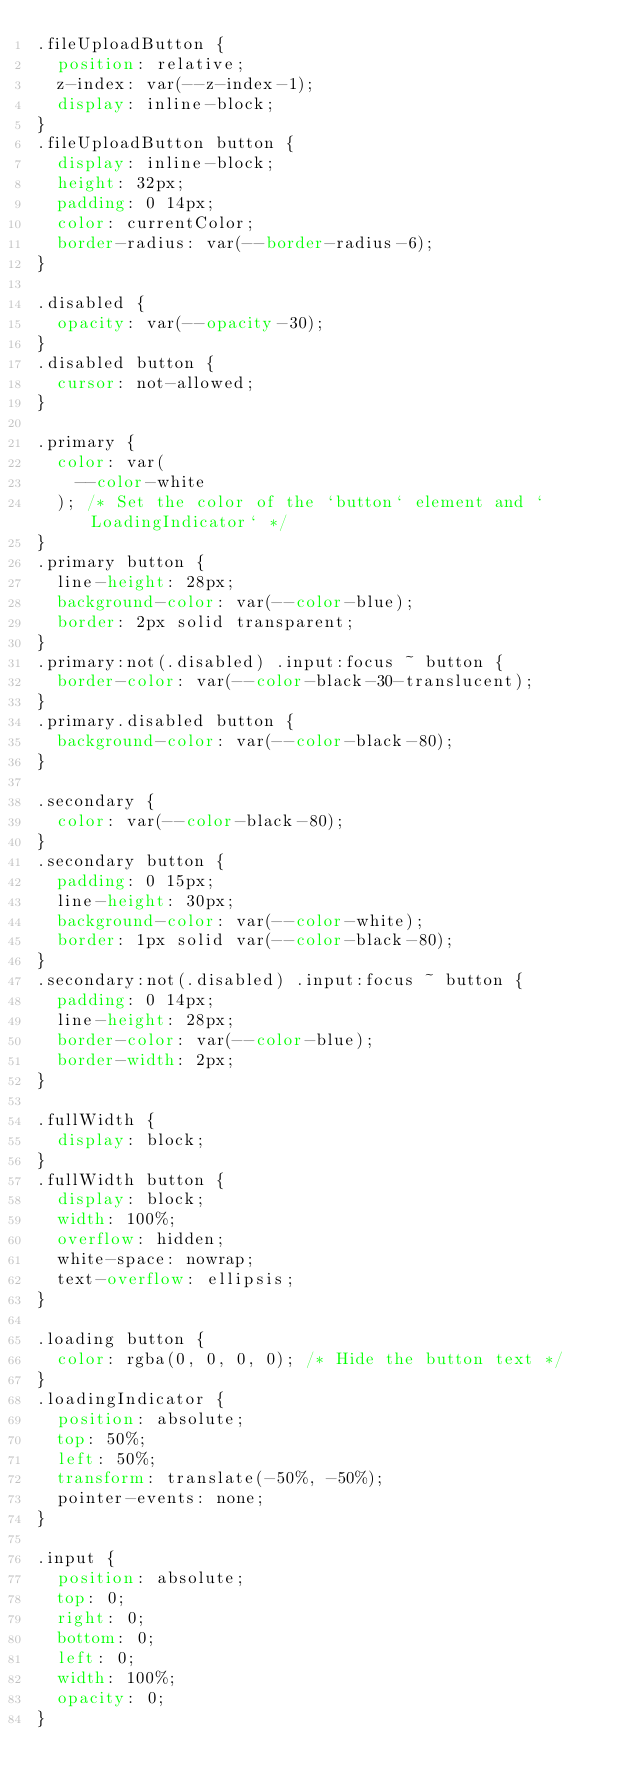Convert code to text. <code><loc_0><loc_0><loc_500><loc_500><_CSS_>.fileUploadButton {
  position: relative;
  z-index: var(--z-index-1);
  display: inline-block;
}
.fileUploadButton button {
  display: inline-block;
  height: 32px;
  padding: 0 14px;
  color: currentColor;
  border-radius: var(--border-radius-6);
}

.disabled {
  opacity: var(--opacity-30);
}
.disabled button {
  cursor: not-allowed;
}

.primary {
  color: var(
    --color-white
  ); /* Set the color of the `button` element and `LoadingIndicator` */
}
.primary button {
  line-height: 28px;
  background-color: var(--color-blue);
  border: 2px solid transparent;
}
.primary:not(.disabled) .input:focus ~ button {
  border-color: var(--color-black-30-translucent);
}
.primary.disabled button {
  background-color: var(--color-black-80);
}

.secondary {
  color: var(--color-black-80);
}
.secondary button {
  padding: 0 15px;
  line-height: 30px;
  background-color: var(--color-white);
  border: 1px solid var(--color-black-80);
}
.secondary:not(.disabled) .input:focus ~ button {
  padding: 0 14px;
  line-height: 28px;
  border-color: var(--color-blue);
  border-width: 2px;
}

.fullWidth {
  display: block;
}
.fullWidth button {
  display: block;
  width: 100%;
  overflow: hidden;
  white-space: nowrap;
  text-overflow: ellipsis;
}

.loading button {
  color: rgba(0, 0, 0, 0); /* Hide the button text */
}
.loadingIndicator {
  position: absolute;
  top: 50%;
  left: 50%;
  transform: translate(-50%, -50%);
  pointer-events: none;
}

.input {
  position: absolute;
  top: 0;
  right: 0;
  bottom: 0;
  left: 0;
  width: 100%;
  opacity: 0;
}
</code> 